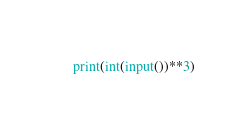Convert code to text. <code><loc_0><loc_0><loc_500><loc_500><_Python_>print(int(input())**3)
</code> 